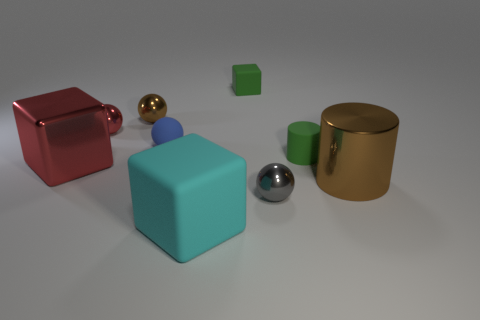What is the shape of the tiny brown object that is the same material as the large cylinder?
Provide a short and direct response. Sphere. The brown metallic object on the left side of the brown object that is to the right of the cylinder that is on the left side of the brown cylinder is what shape?
Your answer should be compact. Sphere. Is the number of small brown metallic balls greater than the number of yellow shiny spheres?
Offer a very short reply. Yes. What material is the red thing that is the same shape as the cyan object?
Provide a succinct answer. Metal. Is the large red cube made of the same material as the brown sphere?
Make the answer very short. Yes. Is the number of metal spheres that are behind the gray thing greater than the number of matte balls?
Keep it short and to the point. Yes. What material is the ball to the right of the cube that is on the right side of the large block that is on the right side of the large red cube made of?
Your answer should be very brief. Metal. What number of objects are metal spheres or things that are in front of the shiny block?
Make the answer very short. 5. Does the cylinder on the left side of the metallic cylinder have the same color as the tiny cube?
Make the answer very short. Yes. Is the number of rubber blocks that are in front of the tiny green cube greater than the number of tiny rubber objects that are right of the gray thing?
Your answer should be very brief. No. 